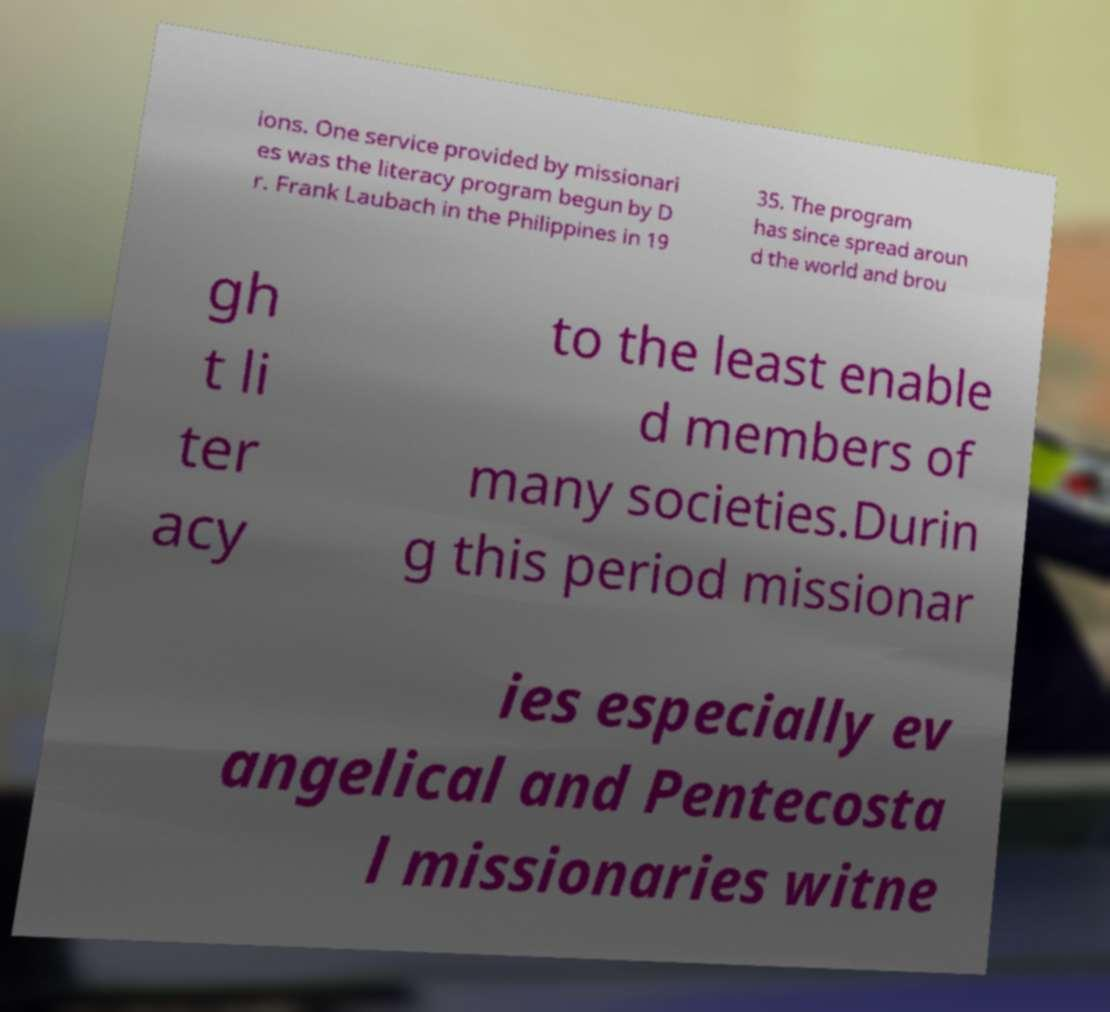Could you assist in decoding the text presented in this image and type it out clearly? ions. One service provided by missionari es was the literacy program begun by D r. Frank Laubach in the Philippines in 19 35. The program has since spread aroun d the world and brou gh t li ter acy to the least enable d members of many societies.Durin g this period missionar ies especially ev angelical and Pentecosta l missionaries witne 